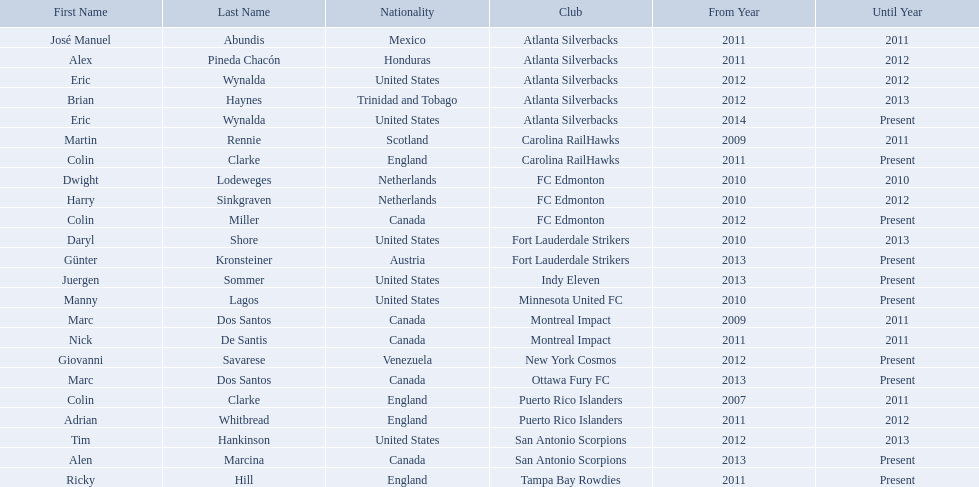What year did marc dos santos start as coach? 2009. Which other starting years correspond with this year? 2009. Who was the other coach with this starting year Martin Rennie. What year did marc dos santos start as coach? 2009. Besides marc dos santos, what other coach started in 2009? Martin Rennie. What were all the coaches who were coaching in 2010? Martin Rennie, Dwight Lodeweges, Harry Sinkgraven, Daryl Shore, Manny Lagos, Marc Dos Santos, Colin Clarke. Which of the 2010 coaches were not born in north america? Martin Rennie, Dwight Lodeweges, Harry Sinkgraven, Colin Clarke. Which coaches that were coaching in 2010 and were not from north america did not coach for fc edmonton? Martin Rennie, Colin Clarke. What coach did not coach for fc edmonton in 2010 and was not north american nationality had the shortened career as a coach? Martin Rennie. 